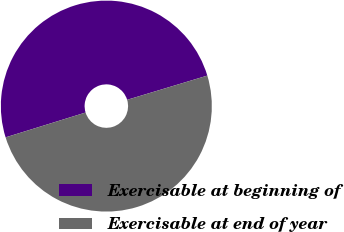Convert chart to OTSL. <chart><loc_0><loc_0><loc_500><loc_500><pie_chart><fcel>Exercisable at beginning of<fcel>Exercisable at end of year<nl><fcel>50.12%<fcel>49.88%<nl></chart> 